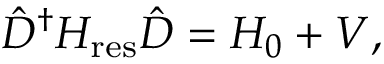<formula> <loc_0><loc_0><loc_500><loc_500>\hat { D } ^ { \dagger } H _ { r e s } \hat { D } = H _ { 0 } + V ,</formula> 